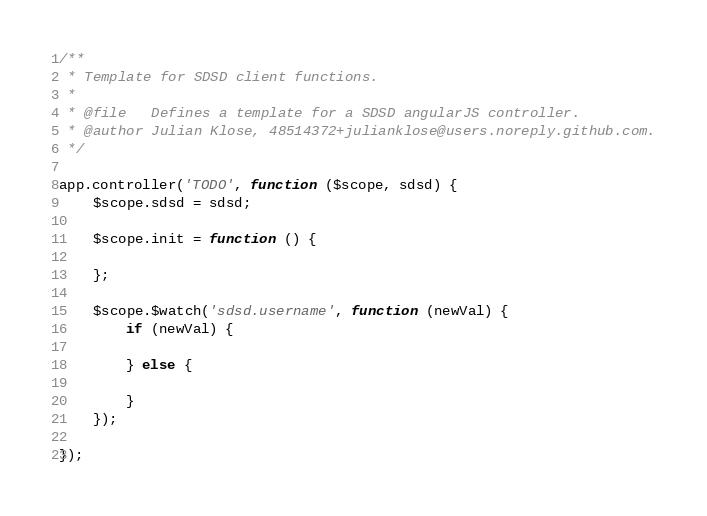<code> <loc_0><loc_0><loc_500><loc_500><_JavaScript_>/**
 * Template for SDSD client functions.
 * 
 * @file   Defines a template for a SDSD angularJS controller.
 * @author Julian Klose, 48514372+julianklose@users.noreply.github.com.
 */

app.controller('TODO', function ($scope, sdsd) {
	$scope.sdsd = sdsd;

	$scope.init = function () {

	};
	
	$scope.$watch('sdsd.username', function (newVal) {
		if (newVal) {

		} else {

		}
	});

});</code> 